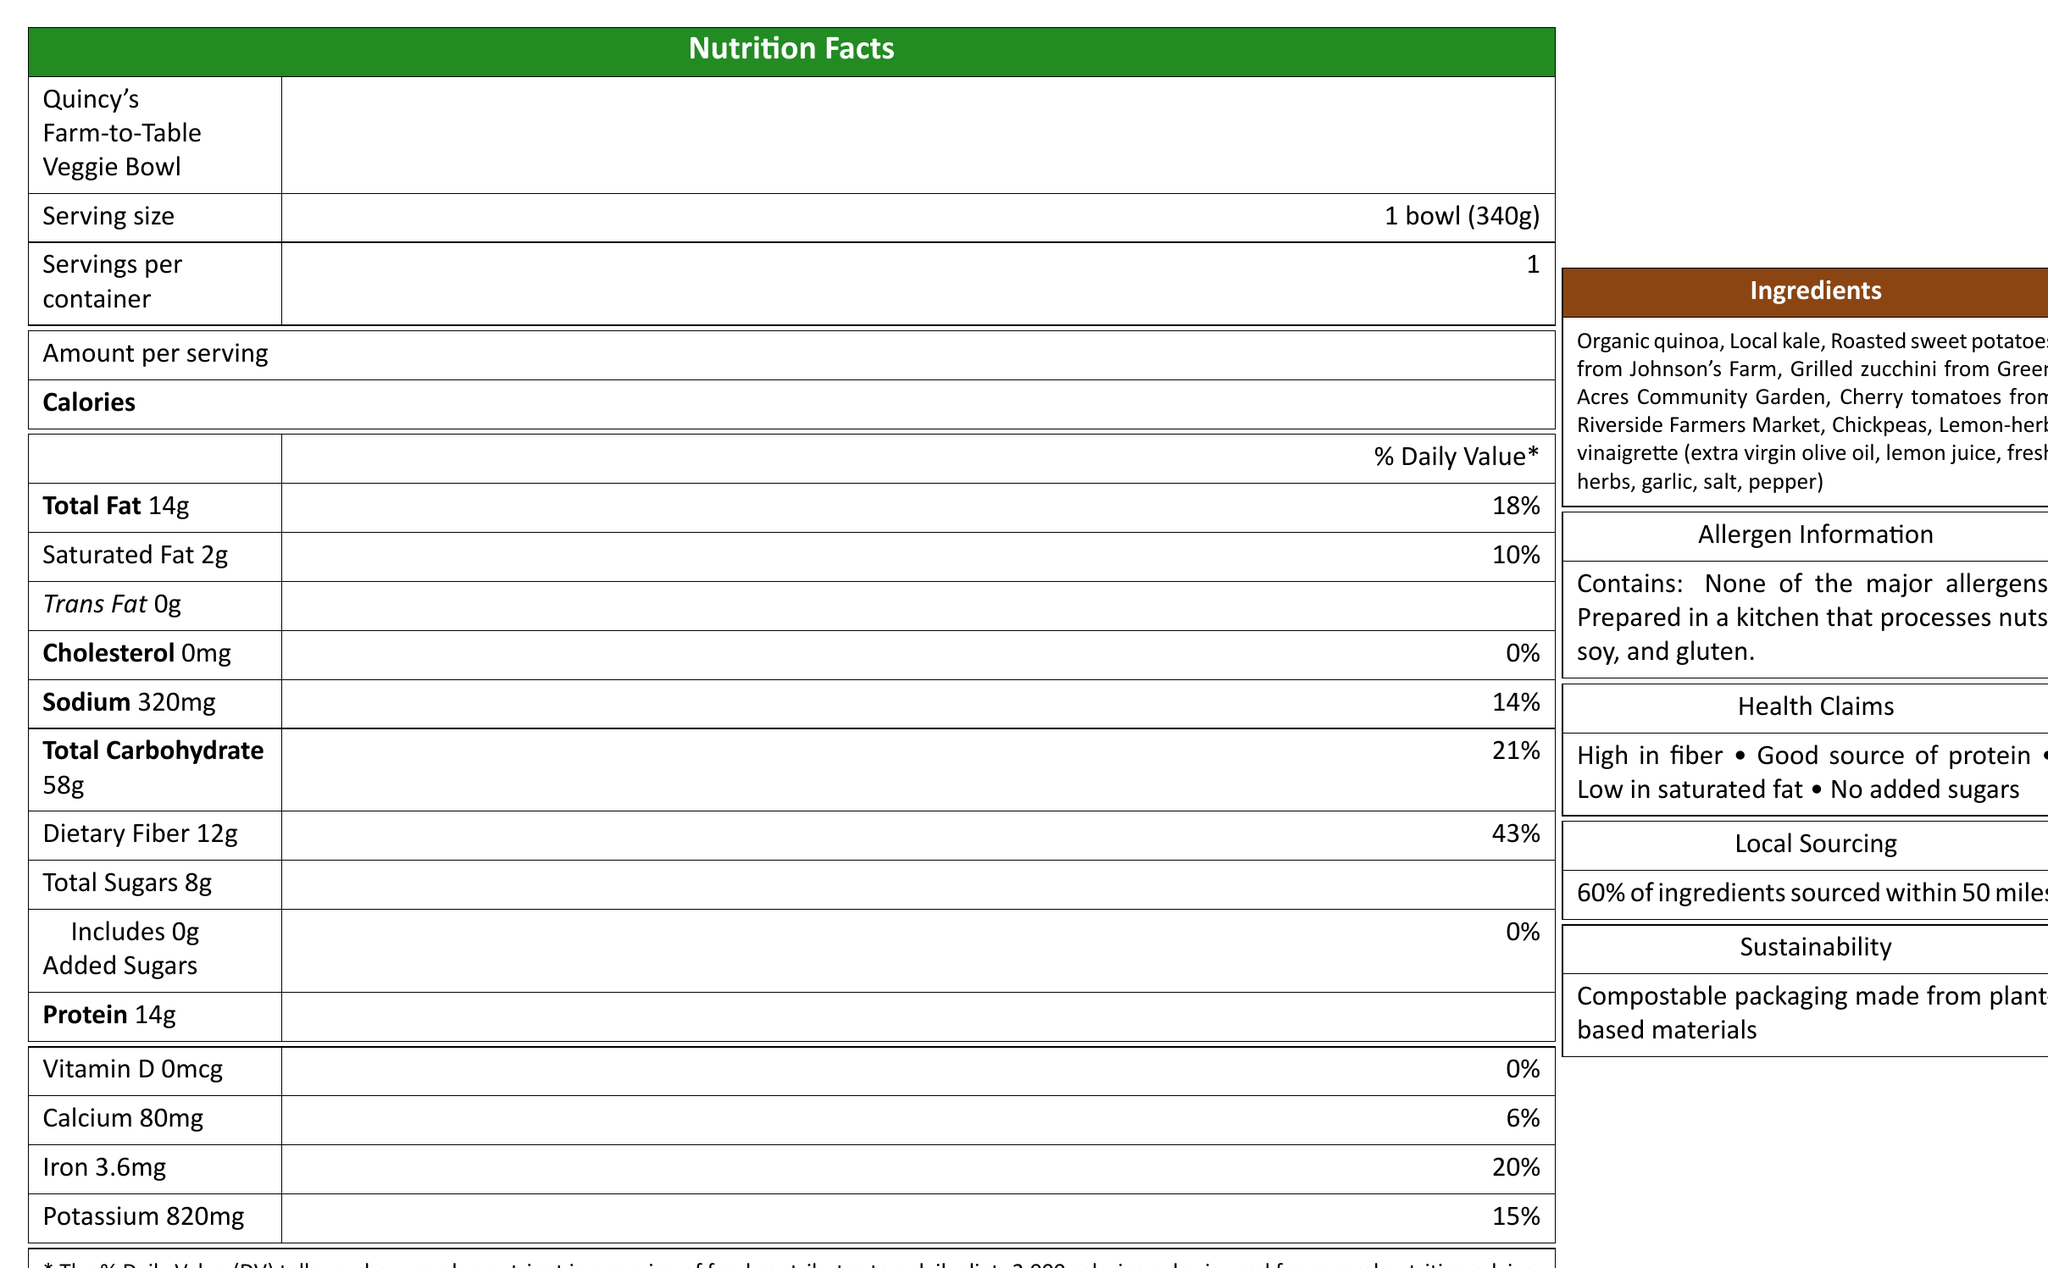what is the serving size of Quincy's Farm-to-Table Veggie Bowl? The document clearly states the serving size as "1 bowl (340g)".
Answer: 1 bowl (340g) How many calories are there per serving? Under the 'Amount per serving' section in the Nutrition Facts table, the calories per serving are listed as 380.
Answer: 380 How much dietary fiber does each serving contain? The document indicates that the veggie bowl contains 12g of dietary fiber per serving.
Answer: 12g Which farm provided the roasted sweet potatoes? The ingredients section specifies that the roasted sweet potatoes are sourced from Johnson's Farm.
Answer: Johnson's Farm What is the percentage of daily value for sodium? The Nutrition Facts table lists the daily value percentage for sodium as 14%.
Answer: 14% How much protein is in the veggie bowl? The Nutrition Facts label indicates that there are 14 grams of protein per serving.
Answer: 14g Does the product contain trans fat? The document lists "Trans Fat 0g", indicating it does not contain trans fat.
Answer: No Which local sources contribute to the ingredients? 1. Johnson's Farm 2. Green Acres Community Garden 3. Riverside Farmers Market 4. All of the above The document mentions ingredients sourced from Johnson's Farm, Green Acres Community Garden, and Riverside Farmers Market, so all options apply.
Answer: 4. All of the above What percentage of the ingredients are sourced within 50 miles? A. 50% B. 60% C. 70% D. 80% The local sourcing section specifies that 60% of the ingredients are sourced within 50 miles.
Answer: B. 60% Is the packaging of the product sustainable? The sustainability notes state that the packaging is compostable and made from plant-based materials.
Answer: Yes Does the product contain any added sugars? The document indicates that there are 0g of added sugars in the product.
Answer: No What percentage of the daily value for iron does one serving contribute? The Nutrition Facts table lists the daily value for iron as 20%.
Answer: 20% Does the document mention if the product was prepared in a kitchen that processes allergens? The allergen information states that the product is prepared in a kitchen that processes nuts, soy, and gluten.
Answer: Yes Summarize the main features presented in the document. The document provides a comprehensive overview of the veggie bowl's nutritional facts, ingredient sourcing, and health benefits, emphasizing its local and sustainable attributes.
Answer: The document describes "Quincy's Farm-to-Table Veggie Bowl," highlighting its nutritional content, ingredients, sourcing practices, and sustainability. The product is high in fiber, a good source of protein, low in saturated fat, and contains no added sugars. It includes locally sourced ingredients from various nearby farms and markets and is packaged in compostable materials. The product does not contain major allergens but is prepared in a kitchen that processes nuts, soy, and gluten. Can I find out the price of the Quincy's Farm-to-Table Veggie Bowl from this document? The document does not provide any information regarding the price of the veggie bowl.
Answer: Not enough information 